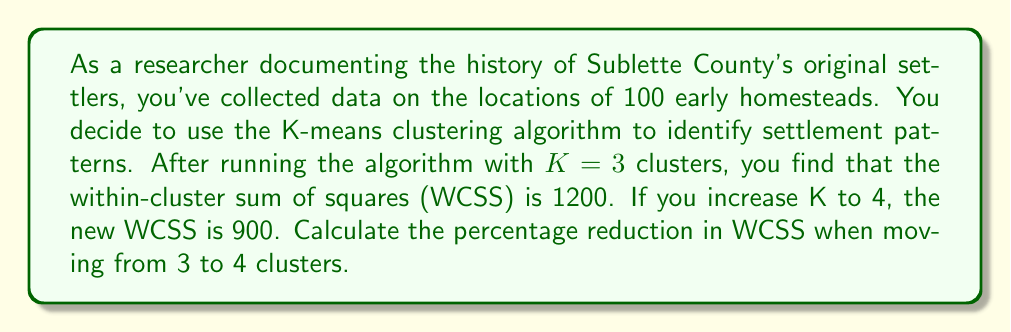Give your solution to this math problem. To solve this problem, we need to follow these steps:

1. Understand the given information:
   - WCSS for K=3: 1200
   - WCSS for K=4: 900

2. Calculate the difference in WCSS:
   $$\text{Difference} = \text{WCSS}_{\text{K=3}} - \text{WCSS}_{\text{K=4}}$$
   $$\text{Difference} = 1200 - 900 = 300$$

3. Calculate the percentage reduction:
   $$\text{Percentage Reduction} = \frac{\text{Difference}}{\text{WCSS}_{\text{K=3}}} \times 100\%$$
   
   $$\text{Percentage Reduction} = \frac{300}{1200} \times 100\%$$
   
   $$\text{Percentage Reduction} = 0.25 \times 100\% = 25\%$$

This calculation shows that increasing the number of clusters from 3 to 4 resulted in a 25% reduction in the within-cluster sum of squares, indicating a potentially significant improvement in the clustering model's fit to the settlement pattern data.
Answer: 25% 